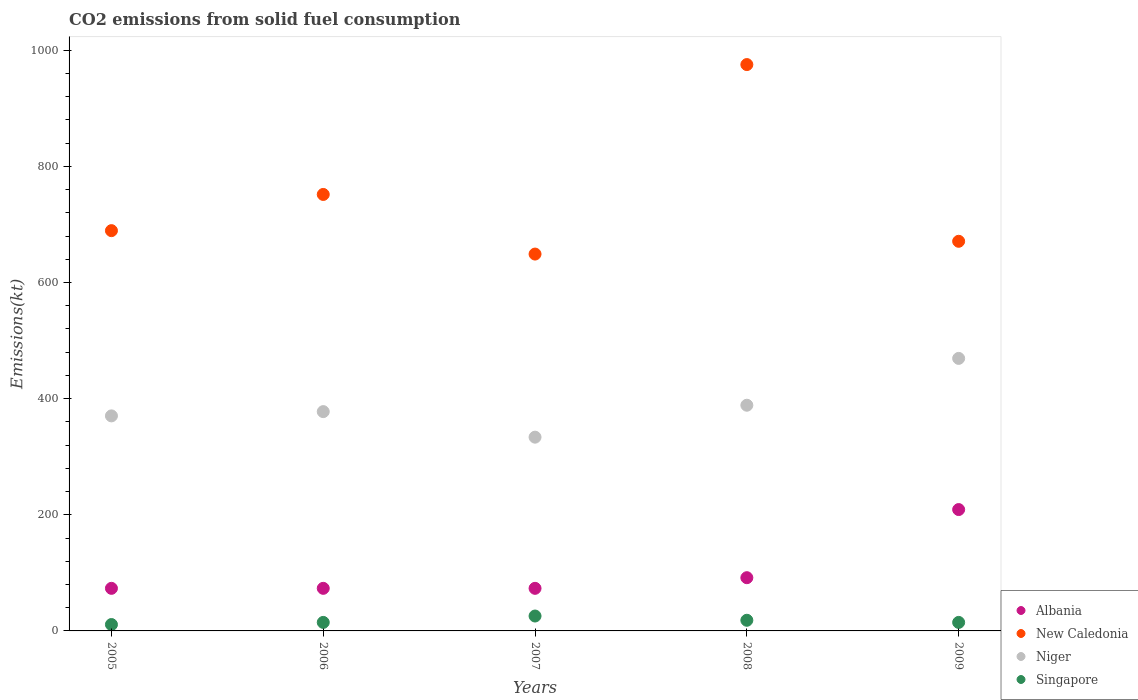How many different coloured dotlines are there?
Your response must be concise. 4. Is the number of dotlines equal to the number of legend labels?
Your answer should be compact. Yes. What is the amount of CO2 emitted in New Caledonia in 2006?
Give a very brief answer. 751.74. Across all years, what is the maximum amount of CO2 emitted in Albania?
Provide a short and direct response. 209.02. Across all years, what is the minimum amount of CO2 emitted in New Caledonia?
Offer a very short reply. 649.06. In which year was the amount of CO2 emitted in Singapore minimum?
Offer a very short reply. 2005. What is the total amount of CO2 emitted in Albania in the graph?
Make the answer very short. 520.71. What is the difference between the amount of CO2 emitted in New Caledonia in 2007 and that in 2009?
Ensure brevity in your answer.  -22. What is the difference between the amount of CO2 emitted in New Caledonia in 2006 and the amount of CO2 emitted in Albania in 2008?
Ensure brevity in your answer.  660.06. What is the average amount of CO2 emitted in Singapore per year?
Give a very brief answer. 16.87. In the year 2008, what is the difference between the amount of CO2 emitted in Albania and amount of CO2 emitted in New Caledonia?
Keep it short and to the point. -883.75. What is the ratio of the amount of CO2 emitted in Niger in 2005 to that in 2009?
Offer a terse response. 0.79. Is the difference between the amount of CO2 emitted in Albania in 2005 and 2007 greater than the difference between the amount of CO2 emitted in New Caledonia in 2005 and 2007?
Give a very brief answer. No. What is the difference between the highest and the second highest amount of CO2 emitted in Albania?
Make the answer very short. 117.34. What is the difference between the highest and the lowest amount of CO2 emitted in Niger?
Your answer should be compact. 135.68. Is the sum of the amount of CO2 emitted in Singapore in 2008 and 2009 greater than the maximum amount of CO2 emitted in Albania across all years?
Give a very brief answer. No. Is it the case that in every year, the sum of the amount of CO2 emitted in Singapore and amount of CO2 emitted in Albania  is greater than the sum of amount of CO2 emitted in New Caledonia and amount of CO2 emitted in Niger?
Offer a very short reply. No. Is it the case that in every year, the sum of the amount of CO2 emitted in Niger and amount of CO2 emitted in New Caledonia  is greater than the amount of CO2 emitted in Albania?
Ensure brevity in your answer.  Yes. Does the amount of CO2 emitted in Albania monotonically increase over the years?
Your answer should be very brief. No. Is the amount of CO2 emitted in Singapore strictly less than the amount of CO2 emitted in Albania over the years?
Provide a succinct answer. Yes. How many years are there in the graph?
Provide a short and direct response. 5. Does the graph contain any zero values?
Ensure brevity in your answer.  No. Where does the legend appear in the graph?
Your answer should be very brief. Bottom right. How are the legend labels stacked?
Ensure brevity in your answer.  Vertical. What is the title of the graph?
Provide a succinct answer. CO2 emissions from solid fuel consumption. What is the label or title of the X-axis?
Give a very brief answer. Years. What is the label or title of the Y-axis?
Give a very brief answer. Emissions(kt). What is the Emissions(kt) of Albania in 2005?
Offer a very short reply. 73.34. What is the Emissions(kt) in New Caledonia in 2005?
Offer a terse response. 689.4. What is the Emissions(kt) of Niger in 2005?
Keep it short and to the point. 370.37. What is the Emissions(kt) of Singapore in 2005?
Keep it short and to the point. 11. What is the Emissions(kt) in Albania in 2006?
Offer a terse response. 73.34. What is the Emissions(kt) of New Caledonia in 2006?
Keep it short and to the point. 751.74. What is the Emissions(kt) of Niger in 2006?
Offer a terse response. 377.7. What is the Emissions(kt) of Singapore in 2006?
Your answer should be very brief. 14.67. What is the Emissions(kt) in Albania in 2007?
Offer a terse response. 73.34. What is the Emissions(kt) in New Caledonia in 2007?
Your answer should be compact. 649.06. What is the Emissions(kt) of Niger in 2007?
Provide a short and direct response. 333.7. What is the Emissions(kt) in Singapore in 2007?
Offer a very short reply. 25.67. What is the Emissions(kt) in Albania in 2008?
Your response must be concise. 91.67. What is the Emissions(kt) in New Caledonia in 2008?
Offer a terse response. 975.42. What is the Emissions(kt) of Niger in 2008?
Ensure brevity in your answer.  388.7. What is the Emissions(kt) in Singapore in 2008?
Provide a short and direct response. 18.34. What is the Emissions(kt) in Albania in 2009?
Your answer should be very brief. 209.02. What is the Emissions(kt) of New Caledonia in 2009?
Offer a terse response. 671.06. What is the Emissions(kt) in Niger in 2009?
Make the answer very short. 469.38. What is the Emissions(kt) of Singapore in 2009?
Give a very brief answer. 14.67. Across all years, what is the maximum Emissions(kt) in Albania?
Your response must be concise. 209.02. Across all years, what is the maximum Emissions(kt) in New Caledonia?
Offer a terse response. 975.42. Across all years, what is the maximum Emissions(kt) of Niger?
Offer a very short reply. 469.38. Across all years, what is the maximum Emissions(kt) in Singapore?
Keep it short and to the point. 25.67. Across all years, what is the minimum Emissions(kt) of Albania?
Your answer should be compact. 73.34. Across all years, what is the minimum Emissions(kt) in New Caledonia?
Provide a short and direct response. 649.06. Across all years, what is the minimum Emissions(kt) of Niger?
Ensure brevity in your answer.  333.7. Across all years, what is the minimum Emissions(kt) in Singapore?
Your response must be concise. 11. What is the total Emissions(kt) in Albania in the graph?
Your answer should be very brief. 520.71. What is the total Emissions(kt) of New Caledonia in the graph?
Your answer should be very brief. 3736.67. What is the total Emissions(kt) in Niger in the graph?
Your response must be concise. 1939.84. What is the total Emissions(kt) of Singapore in the graph?
Make the answer very short. 84.34. What is the difference between the Emissions(kt) of New Caledonia in 2005 and that in 2006?
Keep it short and to the point. -62.34. What is the difference between the Emissions(kt) in Niger in 2005 and that in 2006?
Your answer should be compact. -7.33. What is the difference between the Emissions(kt) in Singapore in 2005 and that in 2006?
Offer a very short reply. -3.67. What is the difference between the Emissions(kt) of New Caledonia in 2005 and that in 2007?
Give a very brief answer. 40.34. What is the difference between the Emissions(kt) in Niger in 2005 and that in 2007?
Keep it short and to the point. 36.67. What is the difference between the Emissions(kt) in Singapore in 2005 and that in 2007?
Offer a terse response. -14.67. What is the difference between the Emissions(kt) in Albania in 2005 and that in 2008?
Keep it short and to the point. -18.34. What is the difference between the Emissions(kt) of New Caledonia in 2005 and that in 2008?
Give a very brief answer. -286.03. What is the difference between the Emissions(kt) of Niger in 2005 and that in 2008?
Your response must be concise. -18.34. What is the difference between the Emissions(kt) in Singapore in 2005 and that in 2008?
Your answer should be very brief. -7.33. What is the difference between the Emissions(kt) of Albania in 2005 and that in 2009?
Your response must be concise. -135.68. What is the difference between the Emissions(kt) of New Caledonia in 2005 and that in 2009?
Give a very brief answer. 18.34. What is the difference between the Emissions(kt) in Niger in 2005 and that in 2009?
Give a very brief answer. -99.01. What is the difference between the Emissions(kt) in Singapore in 2005 and that in 2009?
Ensure brevity in your answer.  -3.67. What is the difference between the Emissions(kt) of Albania in 2006 and that in 2007?
Keep it short and to the point. 0. What is the difference between the Emissions(kt) of New Caledonia in 2006 and that in 2007?
Keep it short and to the point. 102.68. What is the difference between the Emissions(kt) of Niger in 2006 and that in 2007?
Your response must be concise. 44. What is the difference between the Emissions(kt) of Singapore in 2006 and that in 2007?
Offer a very short reply. -11. What is the difference between the Emissions(kt) of Albania in 2006 and that in 2008?
Ensure brevity in your answer.  -18.34. What is the difference between the Emissions(kt) of New Caledonia in 2006 and that in 2008?
Offer a terse response. -223.69. What is the difference between the Emissions(kt) in Niger in 2006 and that in 2008?
Ensure brevity in your answer.  -11. What is the difference between the Emissions(kt) of Singapore in 2006 and that in 2008?
Your response must be concise. -3.67. What is the difference between the Emissions(kt) in Albania in 2006 and that in 2009?
Ensure brevity in your answer.  -135.68. What is the difference between the Emissions(kt) of New Caledonia in 2006 and that in 2009?
Offer a terse response. 80.67. What is the difference between the Emissions(kt) in Niger in 2006 and that in 2009?
Ensure brevity in your answer.  -91.67. What is the difference between the Emissions(kt) of Singapore in 2006 and that in 2009?
Provide a succinct answer. 0. What is the difference between the Emissions(kt) of Albania in 2007 and that in 2008?
Ensure brevity in your answer.  -18.34. What is the difference between the Emissions(kt) of New Caledonia in 2007 and that in 2008?
Offer a very short reply. -326.36. What is the difference between the Emissions(kt) of Niger in 2007 and that in 2008?
Provide a short and direct response. -55.01. What is the difference between the Emissions(kt) of Singapore in 2007 and that in 2008?
Your answer should be compact. 7.33. What is the difference between the Emissions(kt) of Albania in 2007 and that in 2009?
Your answer should be very brief. -135.68. What is the difference between the Emissions(kt) in New Caledonia in 2007 and that in 2009?
Offer a terse response. -22. What is the difference between the Emissions(kt) in Niger in 2007 and that in 2009?
Your response must be concise. -135.68. What is the difference between the Emissions(kt) of Singapore in 2007 and that in 2009?
Make the answer very short. 11. What is the difference between the Emissions(kt) of Albania in 2008 and that in 2009?
Give a very brief answer. -117.34. What is the difference between the Emissions(kt) in New Caledonia in 2008 and that in 2009?
Give a very brief answer. 304.36. What is the difference between the Emissions(kt) of Niger in 2008 and that in 2009?
Ensure brevity in your answer.  -80.67. What is the difference between the Emissions(kt) of Singapore in 2008 and that in 2009?
Keep it short and to the point. 3.67. What is the difference between the Emissions(kt) of Albania in 2005 and the Emissions(kt) of New Caledonia in 2006?
Your answer should be compact. -678.39. What is the difference between the Emissions(kt) of Albania in 2005 and the Emissions(kt) of Niger in 2006?
Offer a very short reply. -304.36. What is the difference between the Emissions(kt) of Albania in 2005 and the Emissions(kt) of Singapore in 2006?
Your answer should be very brief. 58.67. What is the difference between the Emissions(kt) of New Caledonia in 2005 and the Emissions(kt) of Niger in 2006?
Ensure brevity in your answer.  311.69. What is the difference between the Emissions(kt) of New Caledonia in 2005 and the Emissions(kt) of Singapore in 2006?
Give a very brief answer. 674.73. What is the difference between the Emissions(kt) in Niger in 2005 and the Emissions(kt) in Singapore in 2006?
Keep it short and to the point. 355.7. What is the difference between the Emissions(kt) of Albania in 2005 and the Emissions(kt) of New Caledonia in 2007?
Offer a very short reply. -575.72. What is the difference between the Emissions(kt) of Albania in 2005 and the Emissions(kt) of Niger in 2007?
Give a very brief answer. -260.36. What is the difference between the Emissions(kt) in Albania in 2005 and the Emissions(kt) in Singapore in 2007?
Keep it short and to the point. 47.67. What is the difference between the Emissions(kt) of New Caledonia in 2005 and the Emissions(kt) of Niger in 2007?
Offer a terse response. 355.7. What is the difference between the Emissions(kt) of New Caledonia in 2005 and the Emissions(kt) of Singapore in 2007?
Your answer should be compact. 663.73. What is the difference between the Emissions(kt) of Niger in 2005 and the Emissions(kt) of Singapore in 2007?
Your answer should be compact. 344.7. What is the difference between the Emissions(kt) of Albania in 2005 and the Emissions(kt) of New Caledonia in 2008?
Give a very brief answer. -902.08. What is the difference between the Emissions(kt) in Albania in 2005 and the Emissions(kt) in Niger in 2008?
Offer a very short reply. -315.36. What is the difference between the Emissions(kt) of Albania in 2005 and the Emissions(kt) of Singapore in 2008?
Provide a short and direct response. 55.01. What is the difference between the Emissions(kt) in New Caledonia in 2005 and the Emissions(kt) in Niger in 2008?
Your answer should be very brief. 300.69. What is the difference between the Emissions(kt) in New Caledonia in 2005 and the Emissions(kt) in Singapore in 2008?
Ensure brevity in your answer.  671.06. What is the difference between the Emissions(kt) of Niger in 2005 and the Emissions(kt) of Singapore in 2008?
Provide a succinct answer. 352.03. What is the difference between the Emissions(kt) of Albania in 2005 and the Emissions(kt) of New Caledonia in 2009?
Give a very brief answer. -597.72. What is the difference between the Emissions(kt) in Albania in 2005 and the Emissions(kt) in Niger in 2009?
Your answer should be very brief. -396.04. What is the difference between the Emissions(kt) in Albania in 2005 and the Emissions(kt) in Singapore in 2009?
Make the answer very short. 58.67. What is the difference between the Emissions(kt) in New Caledonia in 2005 and the Emissions(kt) in Niger in 2009?
Ensure brevity in your answer.  220.02. What is the difference between the Emissions(kt) of New Caledonia in 2005 and the Emissions(kt) of Singapore in 2009?
Your response must be concise. 674.73. What is the difference between the Emissions(kt) in Niger in 2005 and the Emissions(kt) in Singapore in 2009?
Ensure brevity in your answer.  355.7. What is the difference between the Emissions(kt) in Albania in 2006 and the Emissions(kt) in New Caledonia in 2007?
Provide a short and direct response. -575.72. What is the difference between the Emissions(kt) of Albania in 2006 and the Emissions(kt) of Niger in 2007?
Keep it short and to the point. -260.36. What is the difference between the Emissions(kt) in Albania in 2006 and the Emissions(kt) in Singapore in 2007?
Your response must be concise. 47.67. What is the difference between the Emissions(kt) in New Caledonia in 2006 and the Emissions(kt) in Niger in 2007?
Keep it short and to the point. 418.04. What is the difference between the Emissions(kt) of New Caledonia in 2006 and the Emissions(kt) of Singapore in 2007?
Give a very brief answer. 726.07. What is the difference between the Emissions(kt) of Niger in 2006 and the Emissions(kt) of Singapore in 2007?
Your response must be concise. 352.03. What is the difference between the Emissions(kt) of Albania in 2006 and the Emissions(kt) of New Caledonia in 2008?
Your answer should be compact. -902.08. What is the difference between the Emissions(kt) in Albania in 2006 and the Emissions(kt) in Niger in 2008?
Ensure brevity in your answer.  -315.36. What is the difference between the Emissions(kt) in Albania in 2006 and the Emissions(kt) in Singapore in 2008?
Make the answer very short. 55.01. What is the difference between the Emissions(kt) of New Caledonia in 2006 and the Emissions(kt) of Niger in 2008?
Ensure brevity in your answer.  363.03. What is the difference between the Emissions(kt) of New Caledonia in 2006 and the Emissions(kt) of Singapore in 2008?
Make the answer very short. 733.4. What is the difference between the Emissions(kt) in Niger in 2006 and the Emissions(kt) in Singapore in 2008?
Offer a terse response. 359.37. What is the difference between the Emissions(kt) in Albania in 2006 and the Emissions(kt) in New Caledonia in 2009?
Keep it short and to the point. -597.72. What is the difference between the Emissions(kt) of Albania in 2006 and the Emissions(kt) of Niger in 2009?
Provide a succinct answer. -396.04. What is the difference between the Emissions(kt) of Albania in 2006 and the Emissions(kt) of Singapore in 2009?
Keep it short and to the point. 58.67. What is the difference between the Emissions(kt) in New Caledonia in 2006 and the Emissions(kt) in Niger in 2009?
Offer a very short reply. 282.36. What is the difference between the Emissions(kt) in New Caledonia in 2006 and the Emissions(kt) in Singapore in 2009?
Provide a short and direct response. 737.07. What is the difference between the Emissions(kt) in Niger in 2006 and the Emissions(kt) in Singapore in 2009?
Your answer should be very brief. 363.03. What is the difference between the Emissions(kt) in Albania in 2007 and the Emissions(kt) in New Caledonia in 2008?
Your answer should be compact. -902.08. What is the difference between the Emissions(kt) of Albania in 2007 and the Emissions(kt) of Niger in 2008?
Your answer should be compact. -315.36. What is the difference between the Emissions(kt) in Albania in 2007 and the Emissions(kt) in Singapore in 2008?
Provide a succinct answer. 55.01. What is the difference between the Emissions(kt) of New Caledonia in 2007 and the Emissions(kt) of Niger in 2008?
Provide a succinct answer. 260.36. What is the difference between the Emissions(kt) in New Caledonia in 2007 and the Emissions(kt) in Singapore in 2008?
Provide a succinct answer. 630.72. What is the difference between the Emissions(kt) of Niger in 2007 and the Emissions(kt) of Singapore in 2008?
Offer a terse response. 315.36. What is the difference between the Emissions(kt) in Albania in 2007 and the Emissions(kt) in New Caledonia in 2009?
Ensure brevity in your answer.  -597.72. What is the difference between the Emissions(kt) in Albania in 2007 and the Emissions(kt) in Niger in 2009?
Offer a very short reply. -396.04. What is the difference between the Emissions(kt) of Albania in 2007 and the Emissions(kt) of Singapore in 2009?
Keep it short and to the point. 58.67. What is the difference between the Emissions(kt) in New Caledonia in 2007 and the Emissions(kt) in Niger in 2009?
Offer a terse response. 179.68. What is the difference between the Emissions(kt) of New Caledonia in 2007 and the Emissions(kt) of Singapore in 2009?
Offer a terse response. 634.39. What is the difference between the Emissions(kt) of Niger in 2007 and the Emissions(kt) of Singapore in 2009?
Keep it short and to the point. 319.03. What is the difference between the Emissions(kt) in Albania in 2008 and the Emissions(kt) in New Caledonia in 2009?
Offer a very short reply. -579.39. What is the difference between the Emissions(kt) of Albania in 2008 and the Emissions(kt) of Niger in 2009?
Make the answer very short. -377.7. What is the difference between the Emissions(kt) of Albania in 2008 and the Emissions(kt) of Singapore in 2009?
Your answer should be compact. 77.01. What is the difference between the Emissions(kt) in New Caledonia in 2008 and the Emissions(kt) in Niger in 2009?
Offer a terse response. 506.05. What is the difference between the Emissions(kt) of New Caledonia in 2008 and the Emissions(kt) of Singapore in 2009?
Make the answer very short. 960.75. What is the difference between the Emissions(kt) in Niger in 2008 and the Emissions(kt) in Singapore in 2009?
Your answer should be very brief. 374.03. What is the average Emissions(kt) of Albania per year?
Provide a succinct answer. 104.14. What is the average Emissions(kt) in New Caledonia per year?
Offer a very short reply. 747.33. What is the average Emissions(kt) of Niger per year?
Offer a very short reply. 387.97. What is the average Emissions(kt) of Singapore per year?
Offer a very short reply. 16.87. In the year 2005, what is the difference between the Emissions(kt) in Albania and Emissions(kt) in New Caledonia?
Offer a terse response. -616.06. In the year 2005, what is the difference between the Emissions(kt) in Albania and Emissions(kt) in Niger?
Offer a terse response. -297.03. In the year 2005, what is the difference between the Emissions(kt) of Albania and Emissions(kt) of Singapore?
Offer a terse response. 62.34. In the year 2005, what is the difference between the Emissions(kt) in New Caledonia and Emissions(kt) in Niger?
Offer a very short reply. 319.03. In the year 2005, what is the difference between the Emissions(kt) of New Caledonia and Emissions(kt) of Singapore?
Your response must be concise. 678.39. In the year 2005, what is the difference between the Emissions(kt) of Niger and Emissions(kt) of Singapore?
Ensure brevity in your answer.  359.37. In the year 2006, what is the difference between the Emissions(kt) of Albania and Emissions(kt) of New Caledonia?
Offer a terse response. -678.39. In the year 2006, what is the difference between the Emissions(kt) of Albania and Emissions(kt) of Niger?
Ensure brevity in your answer.  -304.36. In the year 2006, what is the difference between the Emissions(kt) in Albania and Emissions(kt) in Singapore?
Offer a very short reply. 58.67. In the year 2006, what is the difference between the Emissions(kt) in New Caledonia and Emissions(kt) in Niger?
Give a very brief answer. 374.03. In the year 2006, what is the difference between the Emissions(kt) of New Caledonia and Emissions(kt) of Singapore?
Your response must be concise. 737.07. In the year 2006, what is the difference between the Emissions(kt) in Niger and Emissions(kt) in Singapore?
Give a very brief answer. 363.03. In the year 2007, what is the difference between the Emissions(kt) in Albania and Emissions(kt) in New Caledonia?
Your answer should be compact. -575.72. In the year 2007, what is the difference between the Emissions(kt) of Albania and Emissions(kt) of Niger?
Offer a terse response. -260.36. In the year 2007, what is the difference between the Emissions(kt) of Albania and Emissions(kt) of Singapore?
Offer a very short reply. 47.67. In the year 2007, what is the difference between the Emissions(kt) in New Caledonia and Emissions(kt) in Niger?
Provide a short and direct response. 315.36. In the year 2007, what is the difference between the Emissions(kt) in New Caledonia and Emissions(kt) in Singapore?
Offer a terse response. 623.39. In the year 2007, what is the difference between the Emissions(kt) in Niger and Emissions(kt) in Singapore?
Offer a very short reply. 308.03. In the year 2008, what is the difference between the Emissions(kt) in Albania and Emissions(kt) in New Caledonia?
Offer a very short reply. -883.75. In the year 2008, what is the difference between the Emissions(kt) in Albania and Emissions(kt) in Niger?
Provide a short and direct response. -297.03. In the year 2008, what is the difference between the Emissions(kt) of Albania and Emissions(kt) of Singapore?
Offer a very short reply. 73.34. In the year 2008, what is the difference between the Emissions(kt) in New Caledonia and Emissions(kt) in Niger?
Offer a terse response. 586.72. In the year 2008, what is the difference between the Emissions(kt) in New Caledonia and Emissions(kt) in Singapore?
Give a very brief answer. 957.09. In the year 2008, what is the difference between the Emissions(kt) of Niger and Emissions(kt) of Singapore?
Offer a terse response. 370.37. In the year 2009, what is the difference between the Emissions(kt) of Albania and Emissions(kt) of New Caledonia?
Your answer should be very brief. -462.04. In the year 2009, what is the difference between the Emissions(kt) in Albania and Emissions(kt) in Niger?
Your answer should be compact. -260.36. In the year 2009, what is the difference between the Emissions(kt) of Albania and Emissions(kt) of Singapore?
Your answer should be very brief. 194.35. In the year 2009, what is the difference between the Emissions(kt) of New Caledonia and Emissions(kt) of Niger?
Ensure brevity in your answer.  201.69. In the year 2009, what is the difference between the Emissions(kt) in New Caledonia and Emissions(kt) in Singapore?
Make the answer very short. 656.39. In the year 2009, what is the difference between the Emissions(kt) in Niger and Emissions(kt) in Singapore?
Give a very brief answer. 454.71. What is the ratio of the Emissions(kt) of Albania in 2005 to that in 2006?
Provide a short and direct response. 1. What is the ratio of the Emissions(kt) in New Caledonia in 2005 to that in 2006?
Ensure brevity in your answer.  0.92. What is the ratio of the Emissions(kt) in Niger in 2005 to that in 2006?
Offer a very short reply. 0.98. What is the ratio of the Emissions(kt) of Albania in 2005 to that in 2007?
Your answer should be compact. 1. What is the ratio of the Emissions(kt) in New Caledonia in 2005 to that in 2007?
Offer a very short reply. 1.06. What is the ratio of the Emissions(kt) of Niger in 2005 to that in 2007?
Keep it short and to the point. 1.11. What is the ratio of the Emissions(kt) in Singapore in 2005 to that in 2007?
Provide a short and direct response. 0.43. What is the ratio of the Emissions(kt) of Albania in 2005 to that in 2008?
Offer a terse response. 0.8. What is the ratio of the Emissions(kt) of New Caledonia in 2005 to that in 2008?
Your response must be concise. 0.71. What is the ratio of the Emissions(kt) in Niger in 2005 to that in 2008?
Make the answer very short. 0.95. What is the ratio of the Emissions(kt) in Singapore in 2005 to that in 2008?
Offer a terse response. 0.6. What is the ratio of the Emissions(kt) of Albania in 2005 to that in 2009?
Ensure brevity in your answer.  0.35. What is the ratio of the Emissions(kt) in New Caledonia in 2005 to that in 2009?
Offer a very short reply. 1.03. What is the ratio of the Emissions(kt) in Niger in 2005 to that in 2009?
Ensure brevity in your answer.  0.79. What is the ratio of the Emissions(kt) in Albania in 2006 to that in 2007?
Make the answer very short. 1. What is the ratio of the Emissions(kt) in New Caledonia in 2006 to that in 2007?
Keep it short and to the point. 1.16. What is the ratio of the Emissions(kt) of Niger in 2006 to that in 2007?
Provide a succinct answer. 1.13. What is the ratio of the Emissions(kt) of Singapore in 2006 to that in 2007?
Offer a terse response. 0.57. What is the ratio of the Emissions(kt) of Albania in 2006 to that in 2008?
Offer a terse response. 0.8. What is the ratio of the Emissions(kt) in New Caledonia in 2006 to that in 2008?
Your answer should be compact. 0.77. What is the ratio of the Emissions(kt) of Niger in 2006 to that in 2008?
Provide a short and direct response. 0.97. What is the ratio of the Emissions(kt) in Albania in 2006 to that in 2009?
Keep it short and to the point. 0.35. What is the ratio of the Emissions(kt) in New Caledonia in 2006 to that in 2009?
Your answer should be very brief. 1.12. What is the ratio of the Emissions(kt) in Niger in 2006 to that in 2009?
Offer a terse response. 0.8. What is the ratio of the Emissions(kt) in Albania in 2007 to that in 2008?
Keep it short and to the point. 0.8. What is the ratio of the Emissions(kt) of New Caledonia in 2007 to that in 2008?
Offer a very short reply. 0.67. What is the ratio of the Emissions(kt) of Niger in 2007 to that in 2008?
Give a very brief answer. 0.86. What is the ratio of the Emissions(kt) in Singapore in 2007 to that in 2008?
Your response must be concise. 1.4. What is the ratio of the Emissions(kt) in Albania in 2007 to that in 2009?
Keep it short and to the point. 0.35. What is the ratio of the Emissions(kt) of New Caledonia in 2007 to that in 2009?
Ensure brevity in your answer.  0.97. What is the ratio of the Emissions(kt) of Niger in 2007 to that in 2009?
Provide a succinct answer. 0.71. What is the ratio of the Emissions(kt) in Singapore in 2007 to that in 2009?
Give a very brief answer. 1.75. What is the ratio of the Emissions(kt) in Albania in 2008 to that in 2009?
Ensure brevity in your answer.  0.44. What is the ratio of the Emissions(kt) in New Caledonia in 2008 to that in 2009?
Offer a terse response. 1.45. What is the ratio of the Emissions(kt) in Niger in 2008 to that in 2009?
Ensure brevity in your answer.  0.83. What is the difference between the highest and the second highest Emissions(kt) of Albania?
Provide a short and direct response. 117.34. What is the difference between the highest and the second highest Emissions(kt) of New Caledonia?
Offer a very short reply. 223.69. What is the difference between the highest and the second highest Emissions(kt) in Niger?
Keep it short and to the point. 80.67. What is the difference between the highest and the second highest Emissions(kt) in Singapore?
Your answer should be compact. 7.33. What is the difference between the highest and the lowest Emissions(kt) in Albania?
Keep it short and to the point. 135.68. What is the difference between the highest and the lowest Emissions(kt) of New Caledonia?
Your response must be concise. 326.36. What is the difference between the highest and the lowest Emissions(kt) of Niger?
Make the answer very short. 135.68. What is the difference between the highest and the lowest Emissions(kt) of Singapore?
Ensure brevity in your answer.  14.67. 